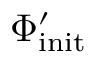Convert formula to latex. <formula><loc_0><loc_0><loc_500><loc_500>\Phi _ { i n i t } ^ { \prime }</formula> 